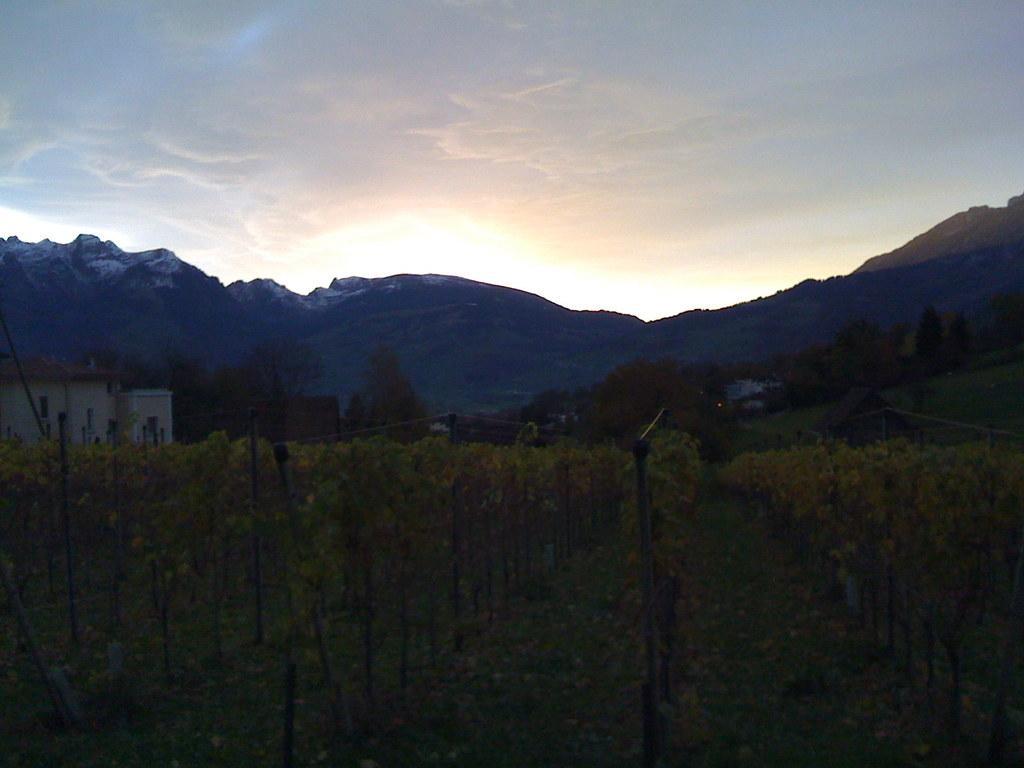Please provide a concise description of this image. In this image we can see group of plants and poles. In the center of the image we can see a building with windows and roof, group of trees. In the background, we can see mountains and the cloudy sky. 